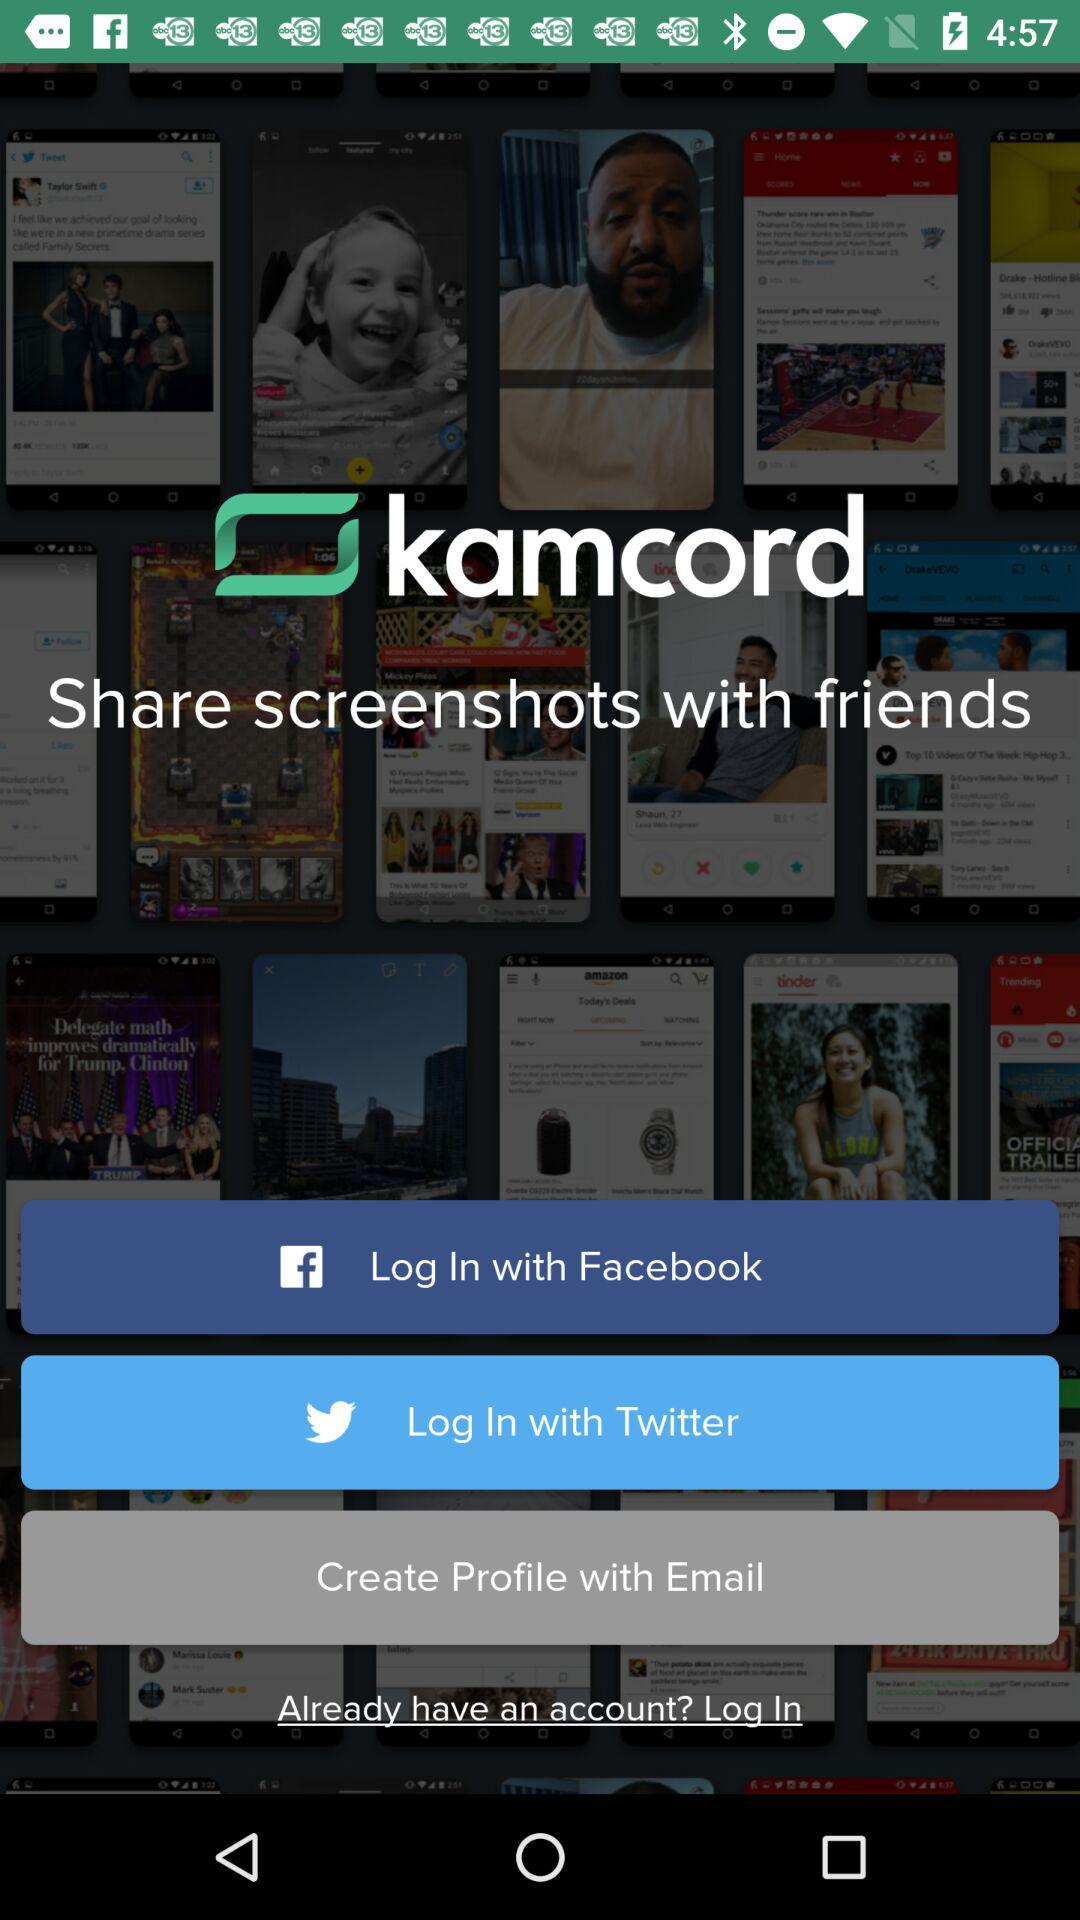Through which accounts can log in be done? Log in can be done through "Facebook", "Twitter" and "Email" accounts. 